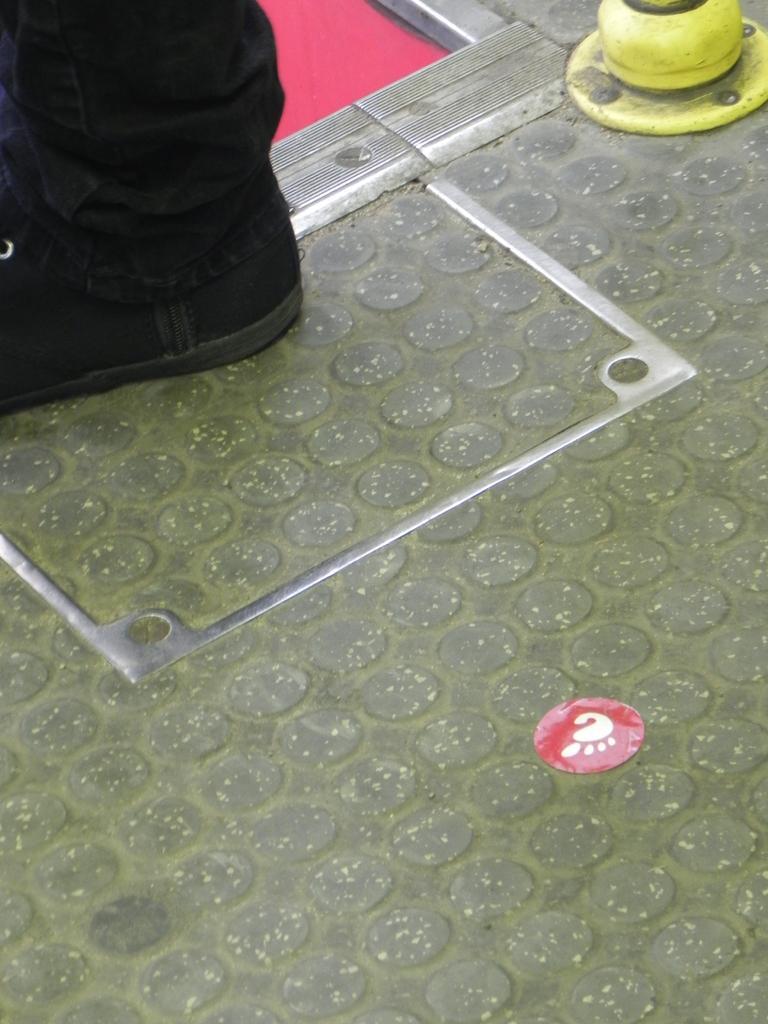Please provide a concise description of this image. In this picture I can see a person leg on the floor, there is a sticker and an object. 